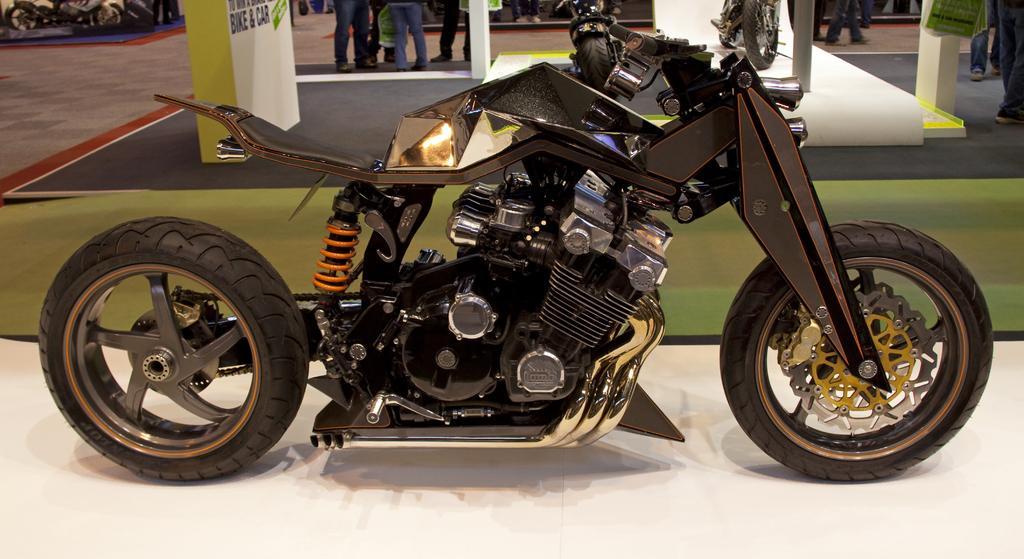In one or two sentences, can you explain what this image depicts? In this picture I can see few motorcycles and few people standing and I can see text on the board. 